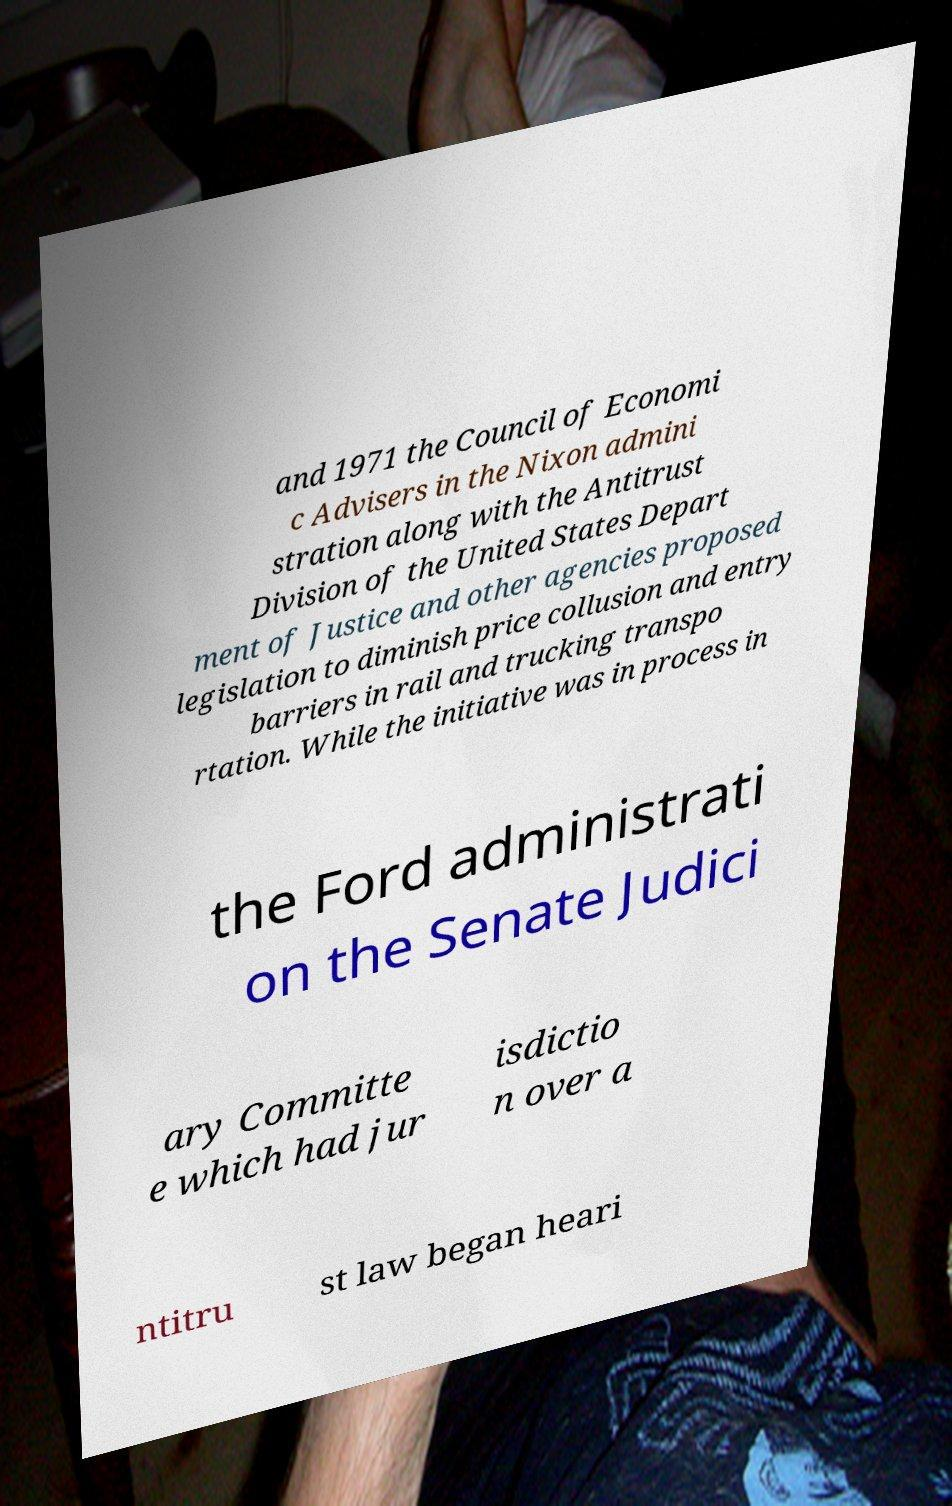Could you assist in decoding the text presented in this image and type it out clearly? and 1971 the Council of Economi c Advisers in the Nixon admini stration along with the Antitrust Division of the United States Depart ment of Justice and other agencies proposed legislation to diminish price collusion and entry barriers in rail and trucking transpo rtation. While the initiative was in process in the Ford administrati on the Senate Judici ary Committe e which had jur isdictio n over a ntitru st law began heari 